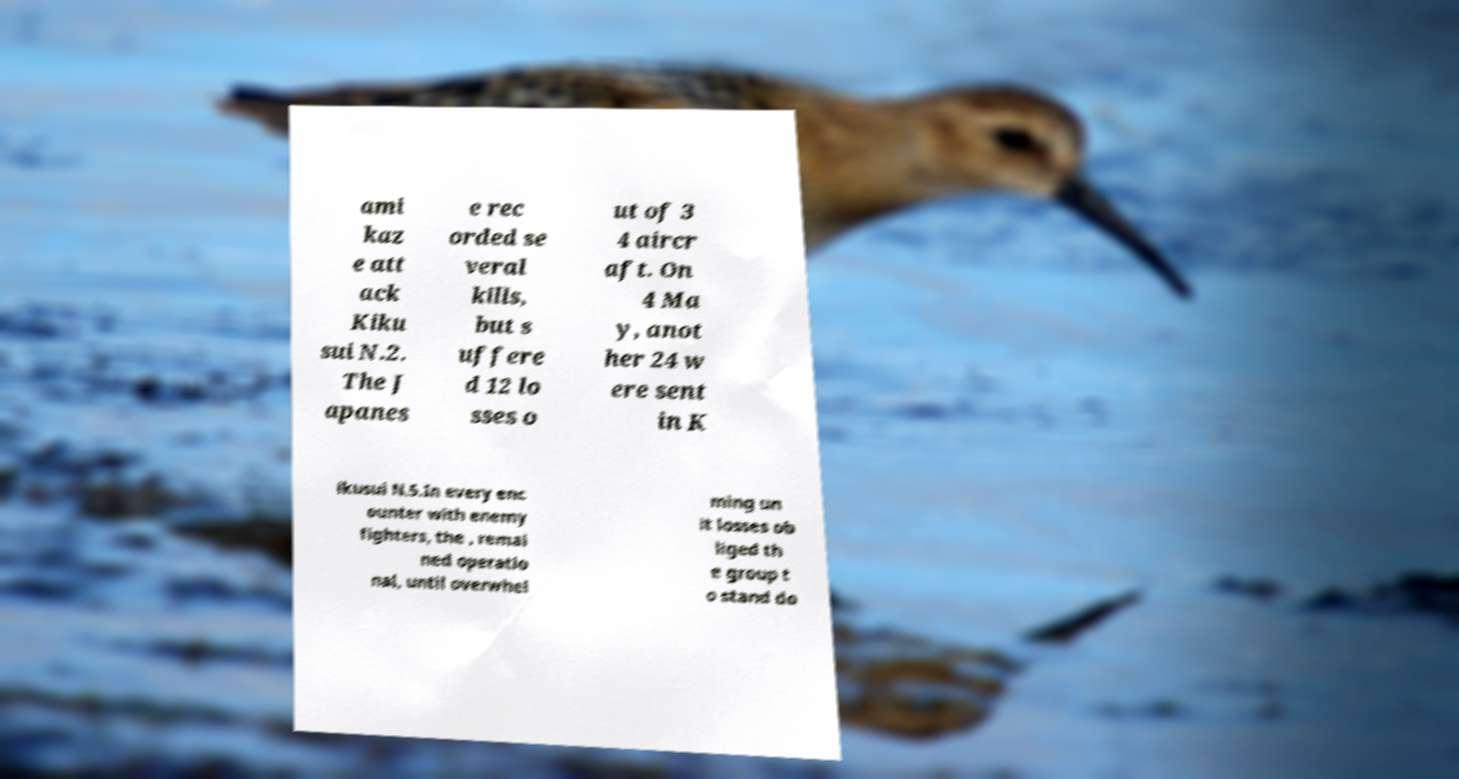There's text embedded in this image that I need extracted. Can you transcribe it verbatim? ami kaz e att ack Kiku sui N.2. The J apanes e rec orded se veral kills, but s uffere d 12 lo sses o ut of 3 4 aircr aft. On 4 Ma y, anot her 24 w ere sent in K ikusui N.5.In every enc ounter with enemy fighters, the , remai ned operatio nal, until overwhel ming un it losses ob liged th e group t o stand do 